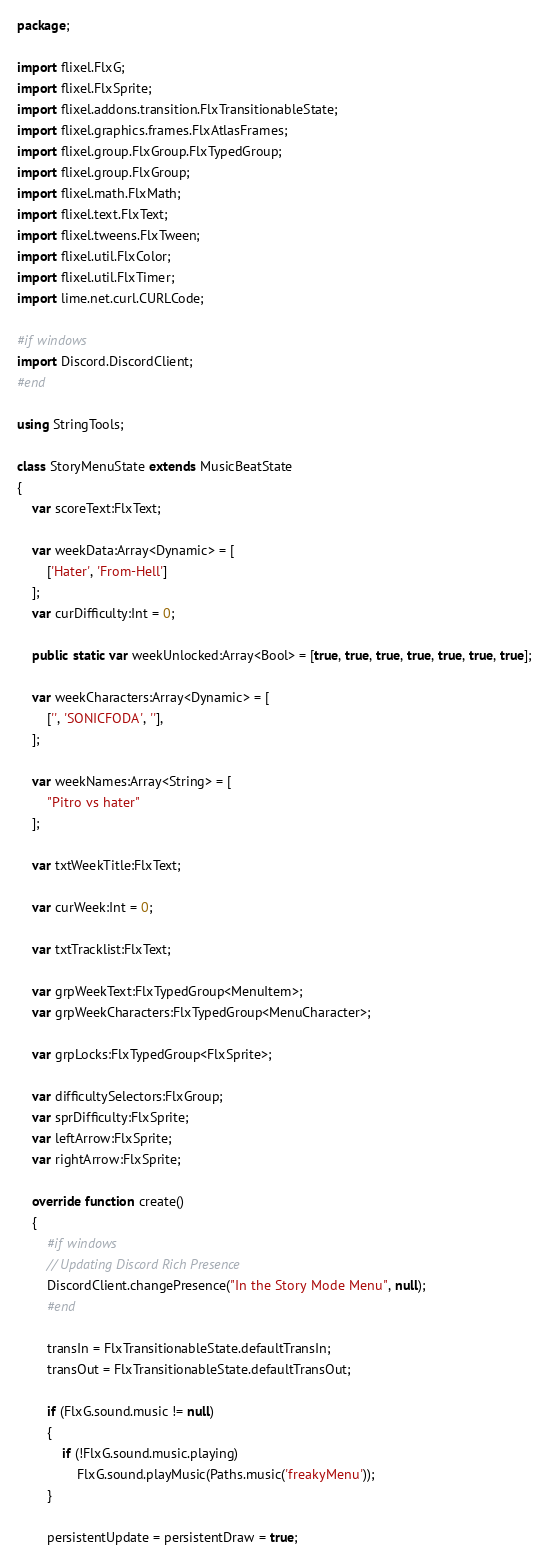<code> <loc_0><loc_0><loc_500><loc_500><_Haxe_>package;

import flixel.FlxG;
import flixel.FlxSprite;
import flixel.addons.transition.FlxTransitionableState;
import flixel.graphics.frames.FlxAtlasFrames;
import flixel.group.FlxGroup.FlxTypedGroup;
import flixel.group.FlxGroup;
import flixel.math.FlxMath;
import flixel.text.FlxText;
import flixel.tweens.FlxTween;
import flixel.util.FlxColor;
import flixel.util.FlxTimer;
import lime.net.curl.CURLCode;

#if windows
import Discord.DiscordClient;
#end

using StringTools;

class StoryMenuState extends MusicBeatState
{
	var scoreText:FlxText;

	var weekData:Array<Dynamic> = [
		['Hater', 'From-Hell']
	];
	var curDifficulty:Int = 0;

	public static var weekUnlocked:Array<Bool> = [true, true, true, true, true, true, true];

	var weekCharacters:Array<Dynamic> = [
		['', 'SONICFODA', ''],
	];

	var weekNames:Array<String> = [
		"Pitro vs hater"
	];

	var txtWeekTitle:FlxText;

	var curWeek:Int = 0;

	var txtTracklist:FlxText;

	var grpWeekText:FlxTypedGroup<MenuItem>;
	var grpWeekCharacters:FlxTypedGroup<MenuCharacter>;

	var grpLocks:FlxTypedGroup<FlxSprite>;

	var difficultySelectors:FlxGroup;
	var sprDifficulty:FlxSprite;
	var leftArrow:FlxSprite;
	var rightArrow:FlxSprite;

	override function create()
	{
		#if windows
		// Updating Discord Rich Presence
		DiscordClient.changePresence("In the Story Mode Menu", null);
		#end

		transIn = FlxTransitionableState.defaultTransIn;
		transOut = FlxTransitionableState.defaultTransOut;

		if (FlxG.sound.music != null)
		{
			if (!FlxG.sound.music.playing)
				FlxG.sound.playMusic(Paths.music('freakyMenu'));
		}

		persistentUpdate = persistentDraw = true;
</code> 